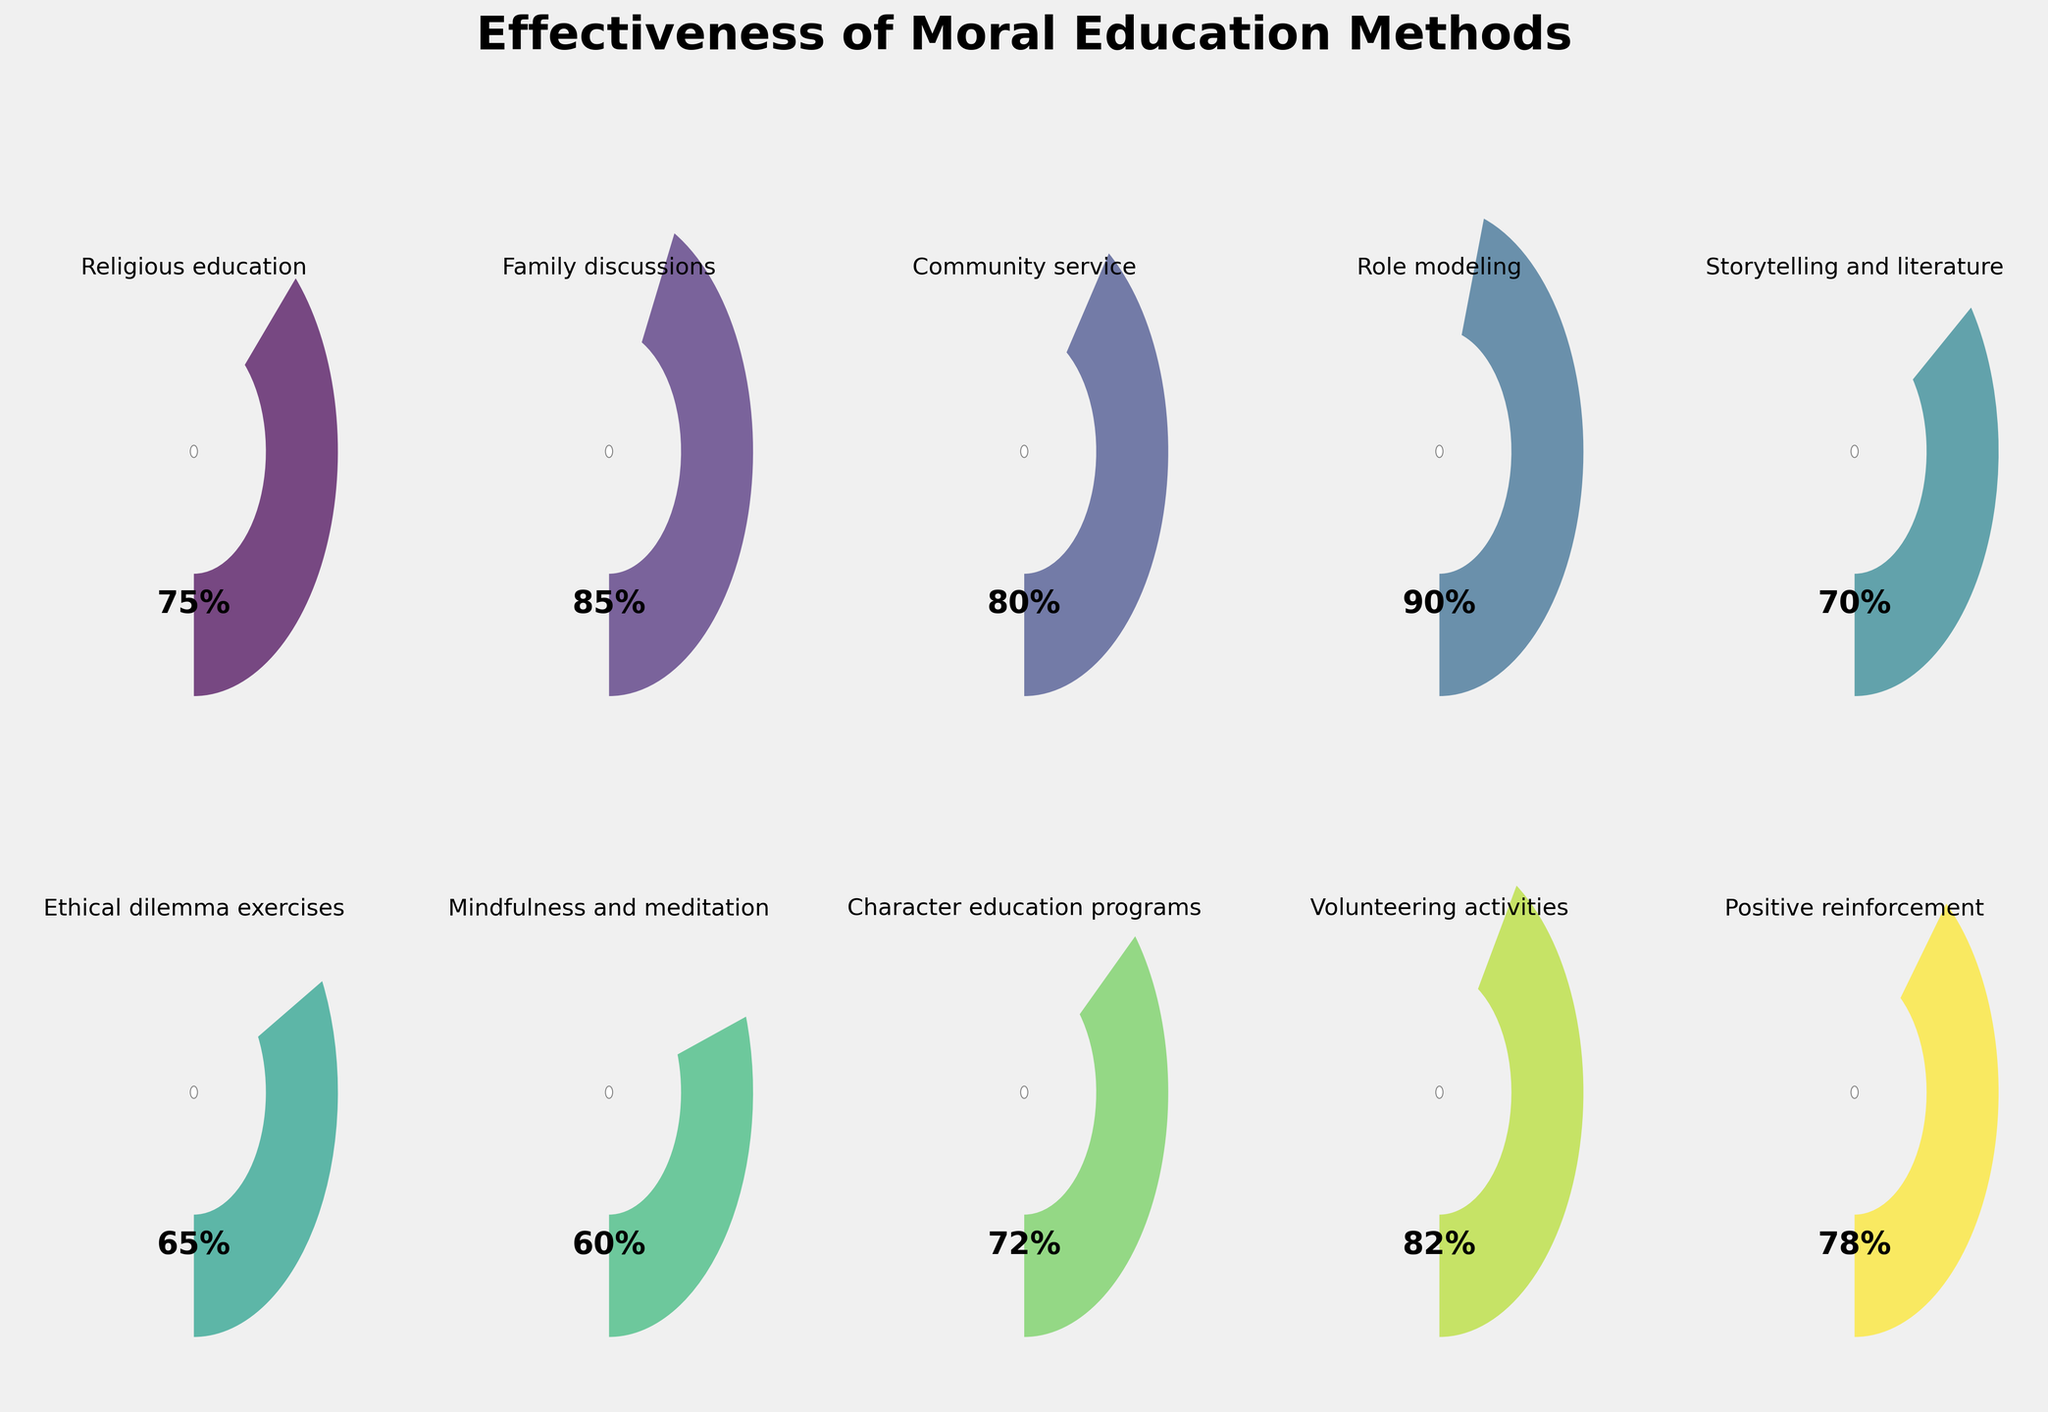Which method of moral education is rated the most effective by experts? The method with the highest effectiveness is identified by looking at the method with the largest value on the gauge. Here, it is 'Role modeling' at 90%.
Answer: Role modeling What is the effectiveness of 'Family discussions'? Look at the gauge labeled 'Family discussions' and note the percentage displayed.
Answer: 85% Which method has the lowest effectiveness rating? Find the method with the smallest value on the gauge, which is 'Mindfulness and meditation' at 60%.
Answer: Mindfulness and meditation How many methods have an effectiveness rating of 80% or higher? Count the number of methods whose gauges display a value of 80% or greater. Based on the figure, they are Family discussions (85%), Community service (80%), Role modeling (90%), and Volunteering activities (82%).
Answer: Four Are there more methods rated above 70% or below 70%? Count the number of methods rated above and below 70%. Methods above 70%: seven (Religious education, Family discussions, Community service, Role modeling, Volunteering activities, Positive reinforcement). Methods below 70%: three (Ethical dilemma exercises, Mindfulness and meditation, Storytelling and literature).
Answer: Above 70% Which methods are less effective than 'Character education programs'? Identify methods with lower effectiveness than 'Character education programs' (72%), and they are 'Mindfulness and meditation' (60%) and 'Ethical dilemma exercises' (65%).
Answer: Mindfulness and meditation, Ethical dilemma exercises What's the average effectiveness rating of all methods? Sum up all effectiveness ratings and divide by the number of methods. (75 + 85 + 80 + 90 + 70 + 65 + 60 + 72 + 82 + 78) = 757, so the average is 757/10 = 75.7.
Answer: 75.7 What is the difference in effectiveness between 'Community service' and 'Positive reinforcement'? Find the gauges for both methods and subtract the effectiveness of 'Positive reinforcement' (78%) from 'Community service' (80%).
Answer: 2% How many methods fall between 60% and 80% effectiveness? Count the methods with effectiveness ratings between 60% and 80%. They are Religious education (75%), Community service (80%), Storytelling and literature (70%), Ethical dilemma exercises (65%), Mindfulness and meditation (60%), Character education programs (72%), Positive reinforcement (78%).
Answer: Seven Which is more effective: 'Volunteering activities' or 'Storytelling and literature'? Compare the effectiveness ratings of both methods. 'Volunteering activities' has an effectiveness rating of 82%, while 'Storytelling and literature' has 70%.
Answer: Volunteering activities 